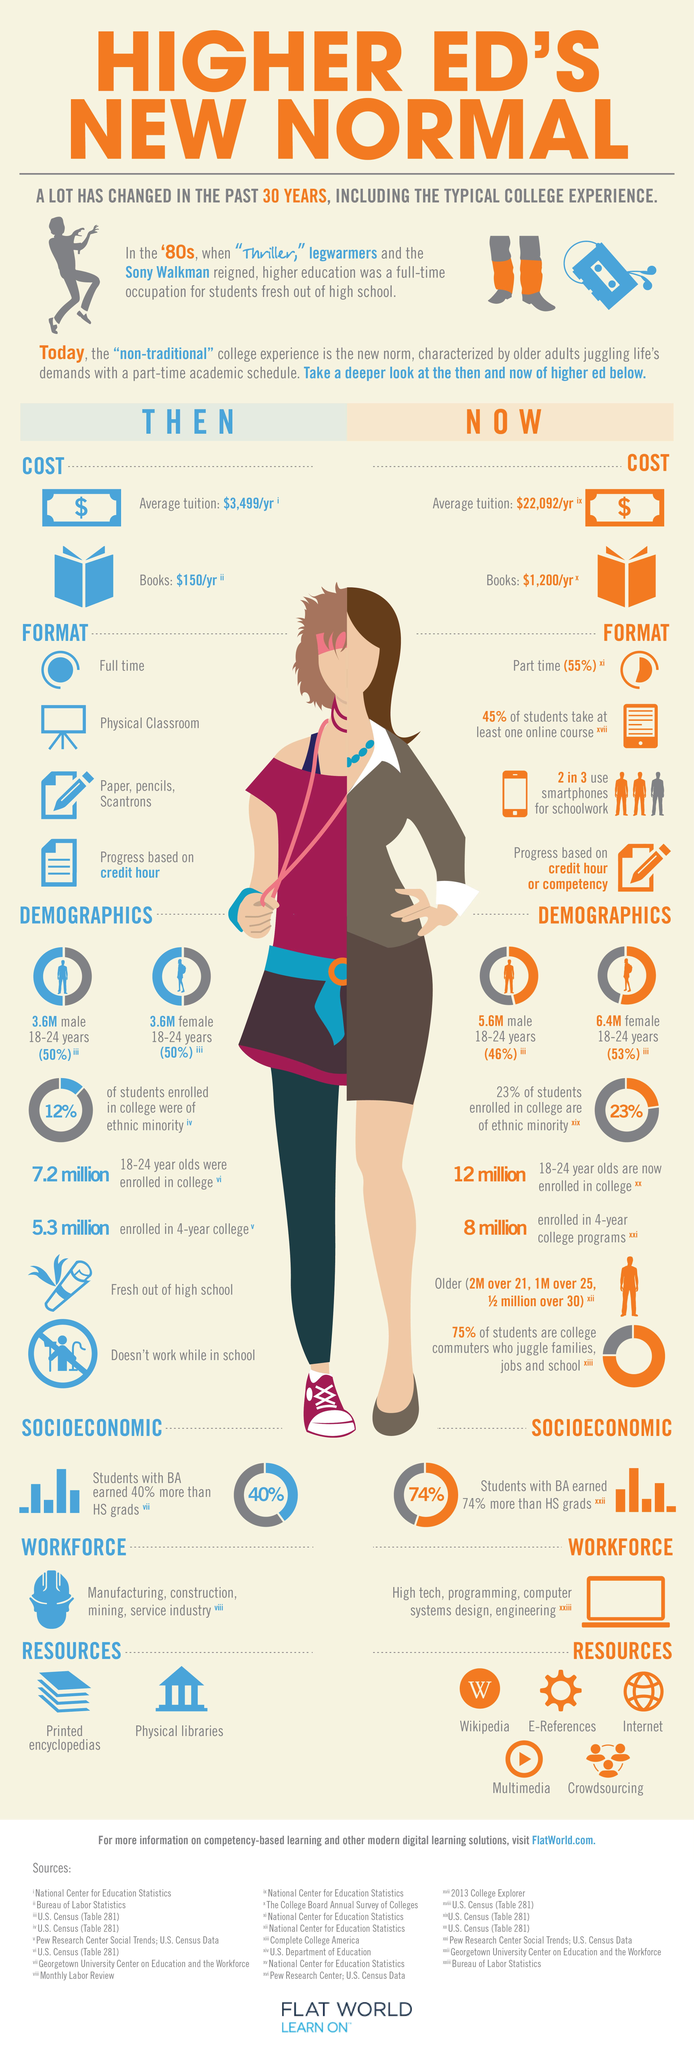Highlight a few significant elements in this photo. It is currently unknown how many resources for college education are being utilized. The cost of tuition fees has increased by $18,593 since 30 years ago, as of now. According to the data, male and female students have a 7% difference in their participation in non-traditional college experiences. In the past two decades, there has been a significant increase in the number of female students seeking education, with a current figure of 2.8 million. The cost of books has increased by $1050 from 30 years ago to the present day. 